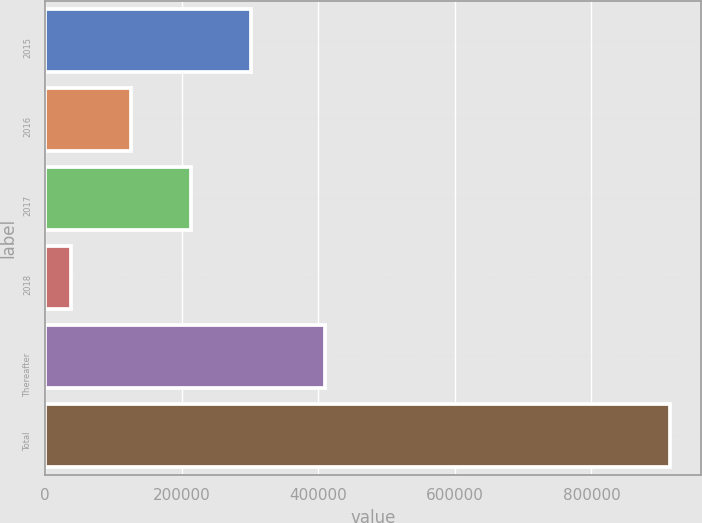Convert chart. <chart><loc_0><loc_0><loc_500><loc_500><bar_chart><fcel>2015<fcel>2016<fcel>2017<fcel>2018<fcel>Thereafter<fcel>Total<nl><fcel>301311<fcel>125976<fcel>213643<fcel>38309<fcel>410231<fcel>914981<nl></chart> 